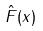Convert formula to latex. <formula><loc_0><loc_0><loc_500><loc_500>\hat { F } ( x )</formula> 